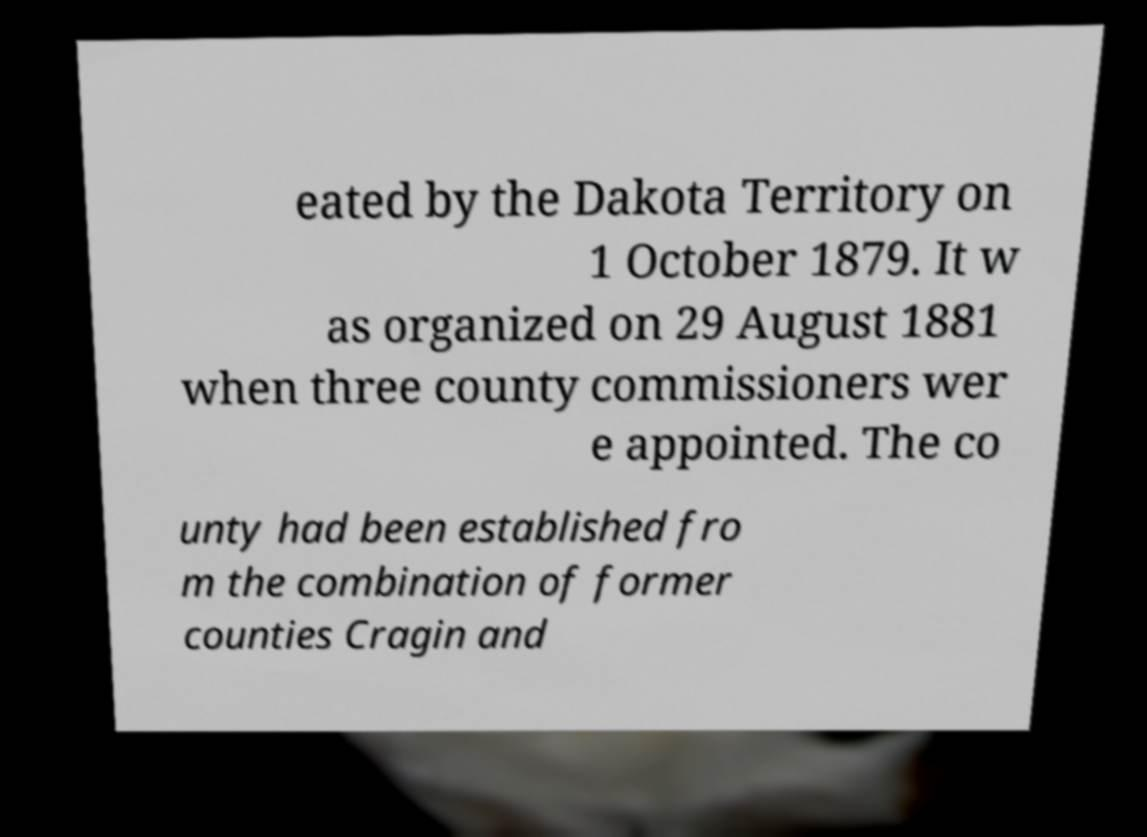Could you assist in decoding the text presented in this image and type it out clearly? eated by the Dakota Territory on 1 October 1879. It w as organized on 29 August 1881 when three county commissioners wer e appointed. The co unty had been established fro m the combination of former counties Cragin and 